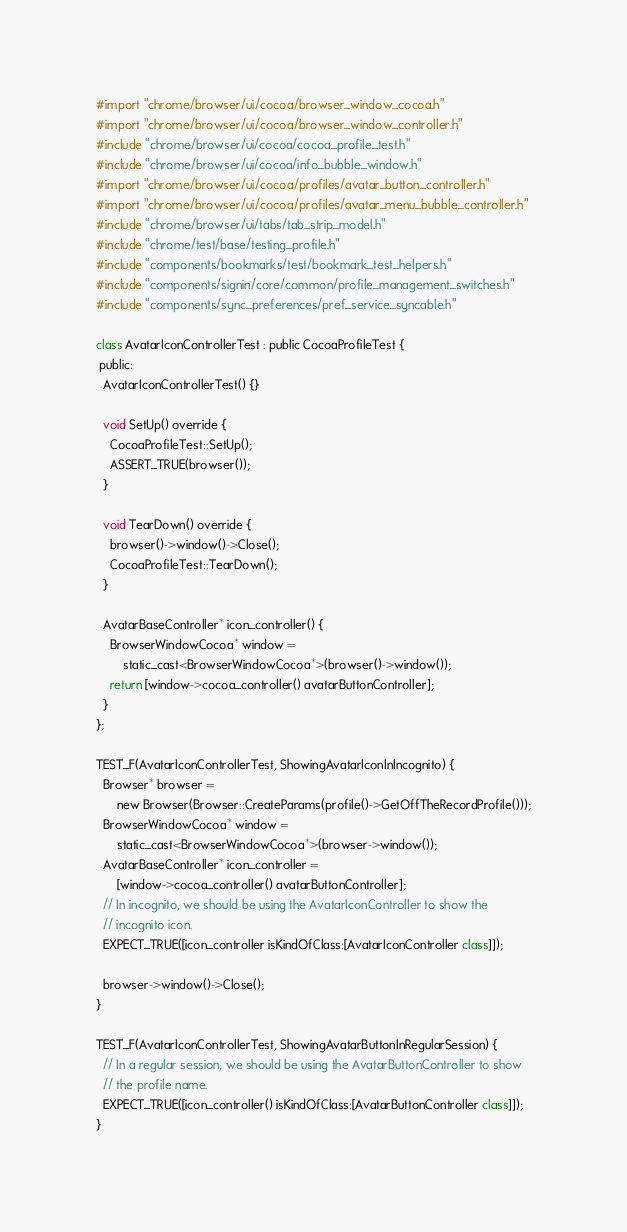Convert code to text. <code><loc_0><loc_0><loc_500><loc_500><_ObjectiveC_>#import "chrome/browser/ui/cocoa/browser_window_cocoa.h"
#import "chrome/browser/ui/cocoa/browser_window_controller.h"
#include "chrome/browser/ui/cocoa/cocoa_profile_test.h"
#include "chrome/browser/ui/cocoa/info_bubble_window.h"
#import "chrome/browser/ui/cocoa/profiles/avatar_button_controller.h"
#import "chrome/browser/ui/cocoa/profiles/avatar_menu_bubble_controller.h"
#include "chrome/browser/ui/tabs/tab_strip_model.h"
#include "chrome/test/base/testing_profile.h"
#include "components/bookmarks/test/bookmark_test_helpers.h"
#include "components/signin/core/common/profile_management_switches.h"
#include "components/sync_preferences/pref_service_syncable.h"

class AvatarIconControllerTest : public CocoaProfileTest {
 public:
  AvatarIconControllerTest() {}

  void SetUp() override {
    CocoaProfileTest::SetUp();
    ASSERT_TRUE(browser());
  }

  void TearDown() override {
    browser()->window()->Close();
    CocoaProfileTest::TearDown();
  }

  AvatarBaseController* icon_controller() {
    BrowserWindowCocoa* window =
        static_cast<BrowserWindowCocoa*>(browser()->window());
    return [window->cocoa_controller() avatarButtonController];
  }
};

TEST_F(AvatarIconControllerTest, ShowingAvatarIconInIncognito) {
  Browser* browser =
      new Browser(Browser::CreateParams(profile()->GetOffTheRecordProfile()));
  BrowserWindowCocoa* window =
      static_cast<BrowserWindowCocoa*>(browser->window());
  AvatarBaseController* icon_controller =
      [window->cocoa_controller() avatarButtonController];
  // In incognito, we should be using the AvatarIconController to show the
  // incognito icon.
  EXPECT_TRUE([icon_controller isKindOfClass:[AvatarIconController class]]);

  browser->window()->Close();
}

TEST_F(AvatarIconControllerTest, ShowingAvatarButtonInRegularSession) {
  // In a regular session, we should be using the AvatarButtonController to show
  // the profile name.
  EXPECT_TRUE([icon_controller() isKindOfClass:[AvatarButtonController class]]);
}
</code> 